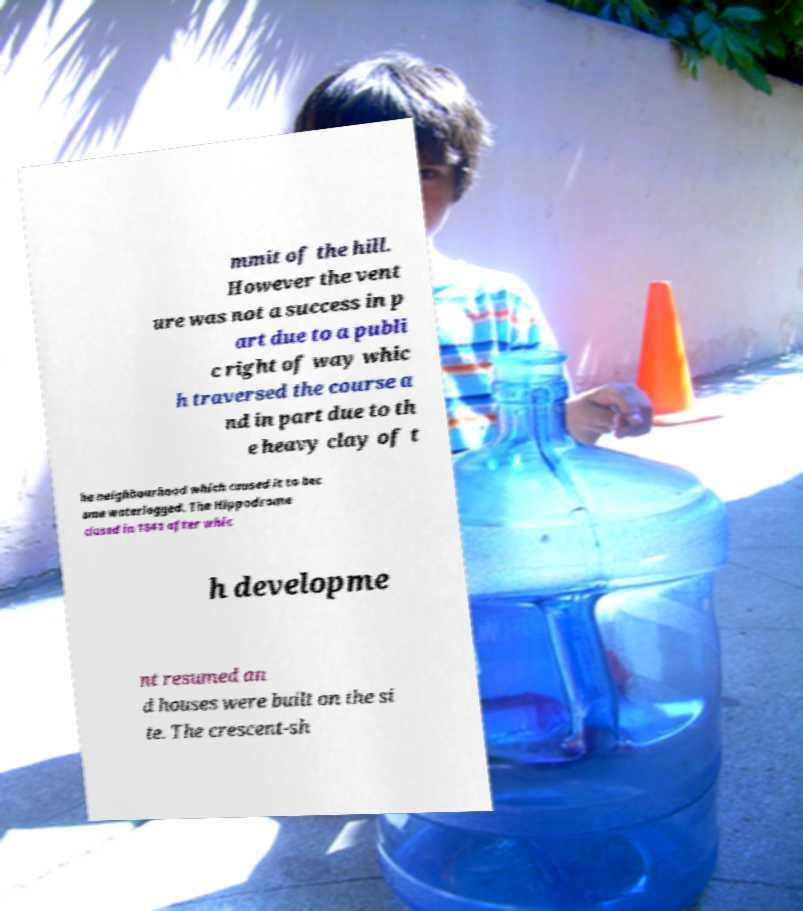For documentation purposes, I need the text within this image transcribed. Could you provide that? mmit of the hill. However the vent ure was not a success in p art due to a publi c right of way whic h traversed the course a nd in part due to th e heavy clay of t he neighbourhood which caused it to bec ome waterlogged. The Hippodrome closed in 1841 after whic h developme nt resumed an d houses were built on the si te. The crescent-sh 